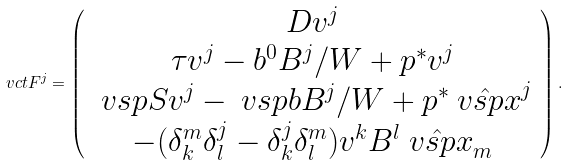Convert formula to latex. <formula><loc_0><loc_0><loc_500><loc_500>\ v c t { F ^ { j } } = \left ( \begin{array} { c } D v ^ { j } \\ \tau v ^ { j } - b ^ { 0 } B ^ { j } / W + p ^ { * } v ^ { j } \\ \ v s p { S } v ^ { j } - \ v s p { b } B ^ { j } / W + p ^ { * } \hat { \ v s p { x } } ^ { j } \\ - ( \delta ^ { m } _ { k } \delta ^ { j } _ { l } - \delta ^ { j } _ { k } \delta ^ { m } _ { l } ) v ^ { k } B ^ { l } \hat { \ v s p { x } } _ { m } \end{array} \right ) .</formula> 